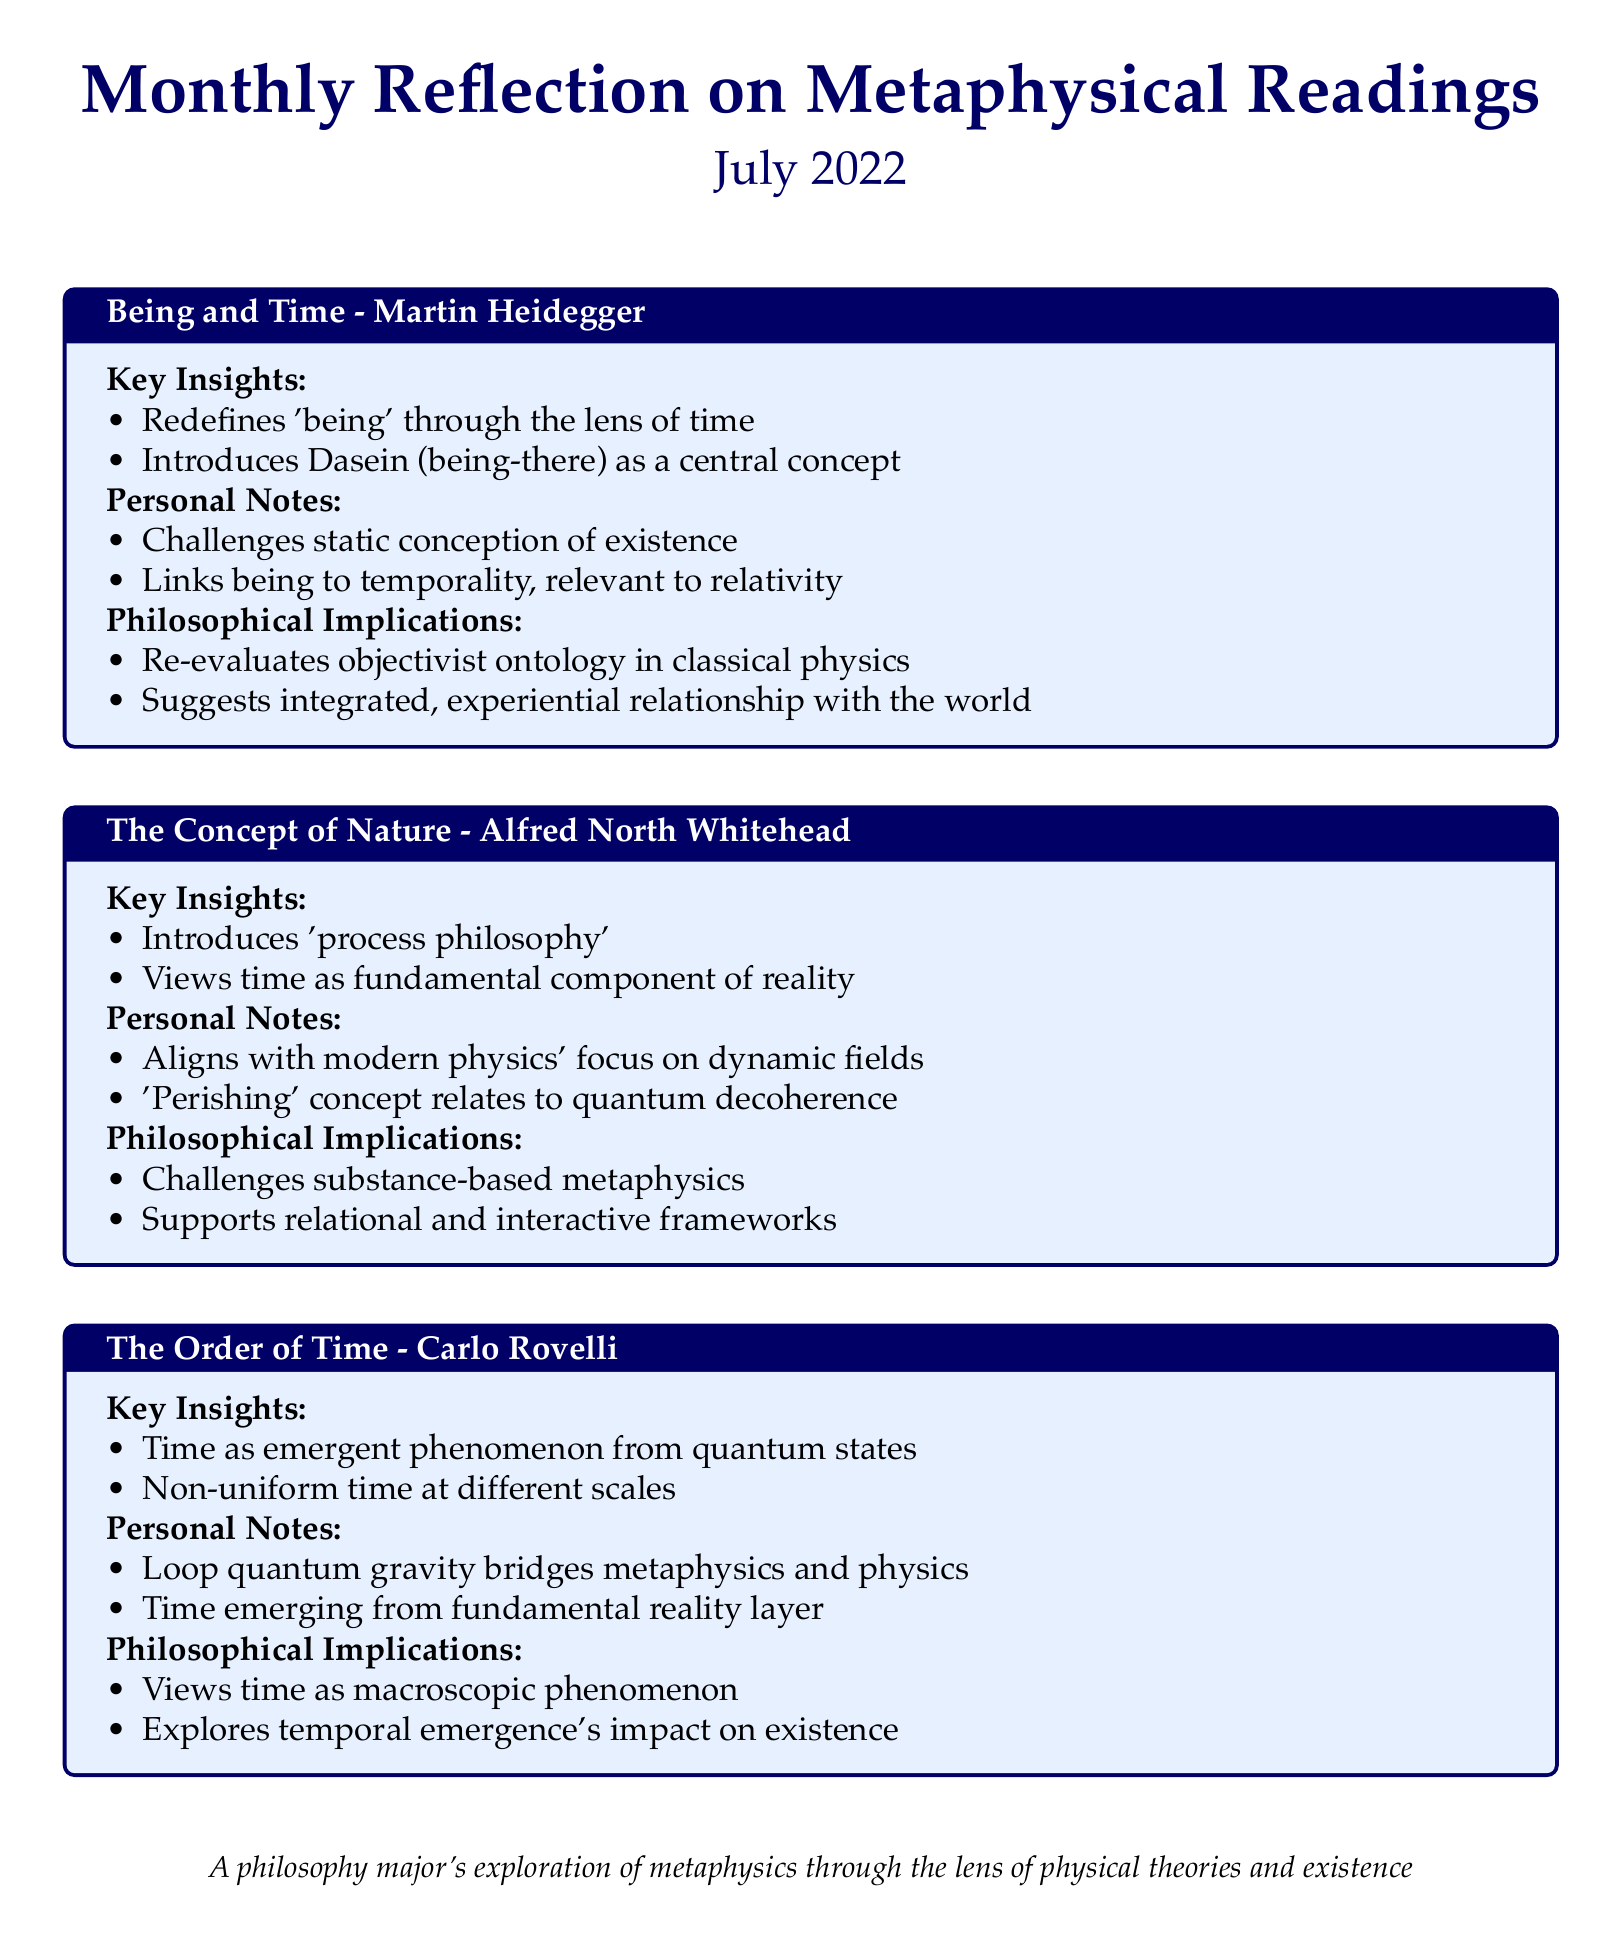What is the title of the first reading? The title is clearly stated in the scorecard under the first tcolorbox.
Answer: Being and Time - Martin Heidegger What concept does Heidegger introduce as central to his philosophy? The document mentions that Heidegger introduces Dasein as a central concept.
Answer: Dasein Which philosopher introduced 'process philosophy'? The text identifies Alfred North Whitehead as the philosopher who introduced this concept.
Answer: Alfred North Whitehead What key component of reality does Whitehead emphasize? The document states that Whitehead views time as a fundamental component of reality.
Answer: Time What type of philosophy does Carlo Rovelli's reading focus on? The reading focuses on the emergent phenomenon of time from quantum states, as noted in the key insights.
Answer: Emergent phenomenon What is one personal note mentioned regarding Rovelli's perspective? The document provides personal notes that mention loop quantum gravity as a key topic in Rovelli's discussion.
Answer: Loop quantum gravity How does Whitehead's view challenge traditional metaphysics? The text outlines that Whitehead's perspective challenges substance-based metaphysics, which provides insight into philosophical implications.
Answer: Substance-based metaphysics What month and year is the reflection covering? The document specifies the month and year of the reflection at the beginning.
Answer: July 2022 What is the overall theme of the monthly reflection? The theme is described in the small text at the bottom of the document, focusing on metaphysics through physical theories.
Answer: Metaphysics through physical theories 